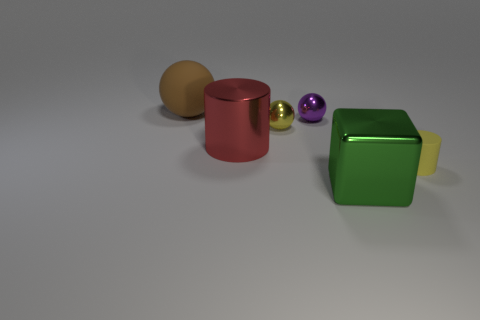Add 4 cyan matte objects. How many objects exist? 10 Subtract all cubes. How many objects are left? 5 Add 5 rubber cylinders. How many rubber cylinders are left? 6 Add 5 large green metallic things. How many large green metallic things exist? 6 Subtract 0 gray cubes. How many objects are left? 6 Subtract all big cyan metal spheres. Subtract all big blocks. How many objects are left? 5 